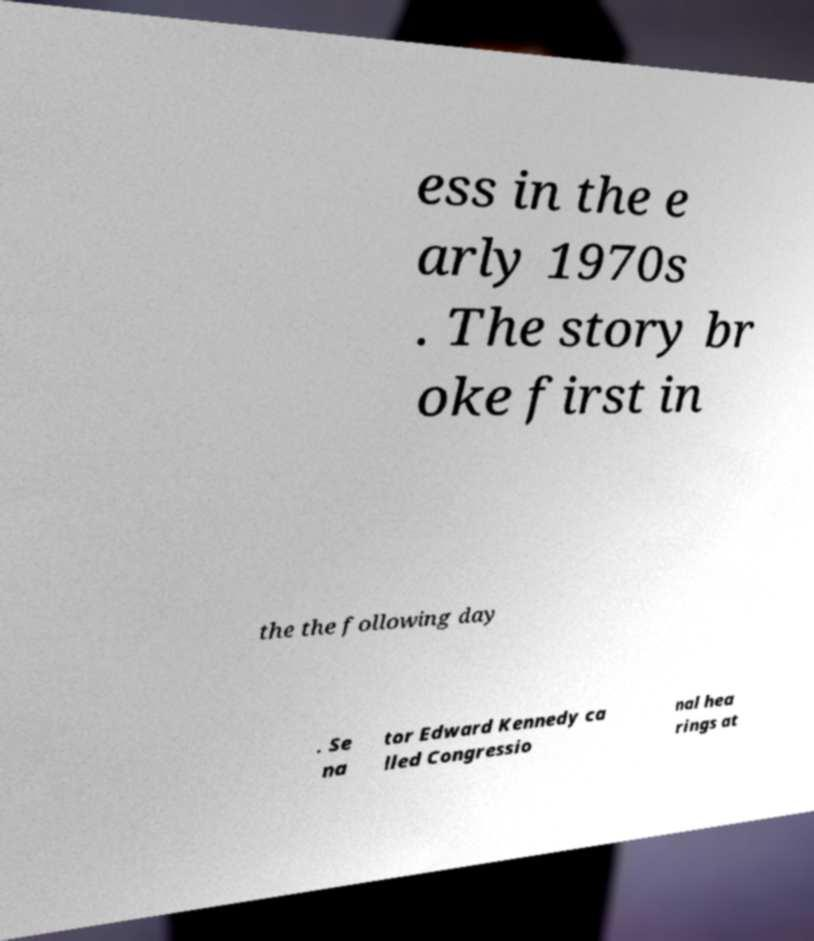Please identify and transcribe the text found in this image. ess in the e arly 1970s . The story br oke first in the the following day . Se na tor Edward Kennedy ca lled Congressio nal hea rings at 